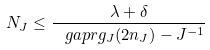<formula> <loc_0><loc_0><loc_500><loc_500>N _ { J } \leq \frac { \lambda + \delta } { \ g a p r g _ { J } ( 2 n _ { J } ) - J ^ { - 1 } }</formula> 